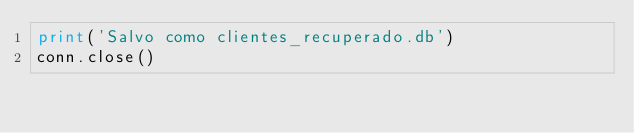Convert code to text. <code><loc_0><loc_0><loc_500><loc_500><_Python_>print('Salvo como clientes_recuperado.db')
conn.close()
</code> 